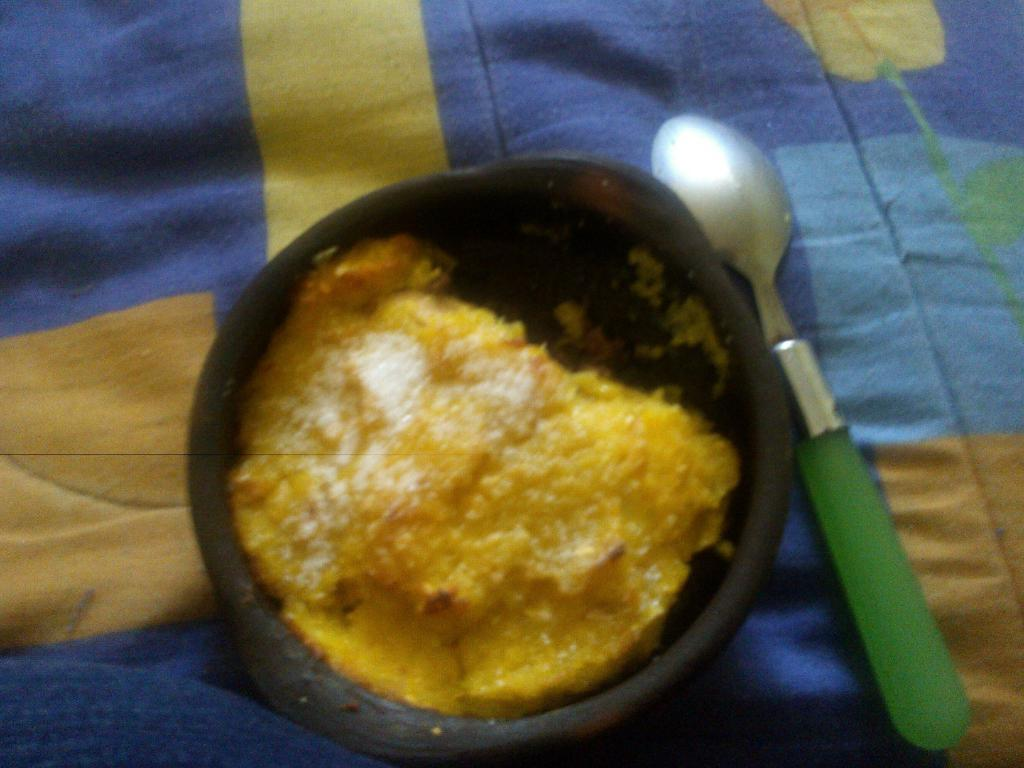What type of container holds the food in the image? There is food in a black bowl in the image. What utensil is placed on the bed in the image? There is a spoon placed on the bed in the image. Where is the hen located in the image? There is no hen present in the image. What type of activity is happening in the park in the image? There is no park or any activity related to a park present in the image. 